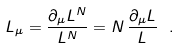<formula> <loc_0><loc_0><loc_500><loc_500>L _ { \mu } = \frac { \partial _ { \mu } L ^ { N } } { L ^ { N } } = N \, \frac { \partial _ { \mu } L } { L } \ .</formula> 